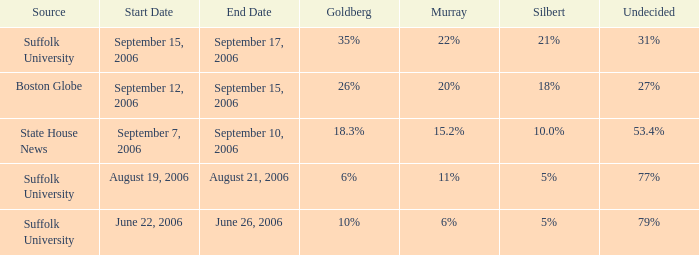What is the undecided percentage of the poll from Suffolk University with Murray at 11%? 77%. 